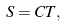Convert formula to latex. <formula><loc_0><loc_0><loc_500><loc_500>S = C T ,</formula> 